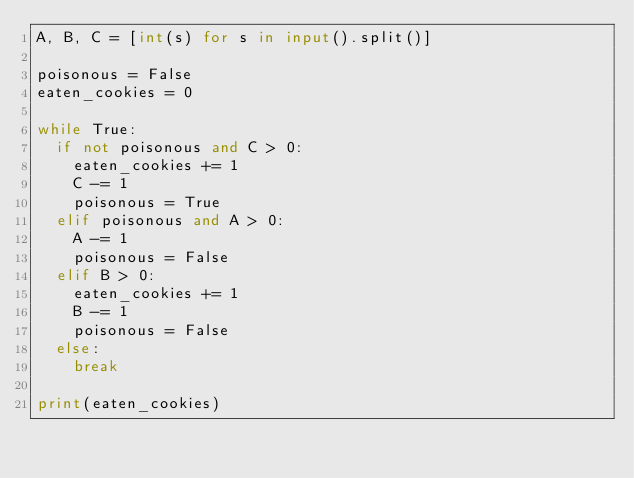<code> <loc_0><loc_0><loc_500><loc_500><_Python_>A, B, C = [int(s) for s in input().split()]

poisonous = False
eaten_cookies = 0

while True:
  if not poisonous and C > 0:
    eaten_cookies += 1
    C -= 1
    poisonous = True
  elif poisonous and A > 0:
    A -= 1
    poisonous = False
  elif B > 0:
    eaten_cookies += 1
    B -= 1
    poisonous = False
  else:
    break

print(eaten_cookies)</code> 